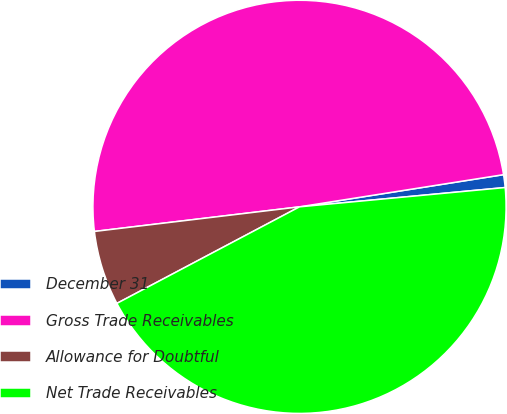Convert chart to OTSL. <chart><loc_0><loc_0><loc_500><loc_500><pie_chart><fcel>December 31<fcel>Gross Trade Receivables<fcel>Allowance for Doubtful<fcel>Net Trade Receivables<nl><fcel>1.0%<fcel>49.41%<fcel>5.84%<fcel>43.75%<nl></chart> 